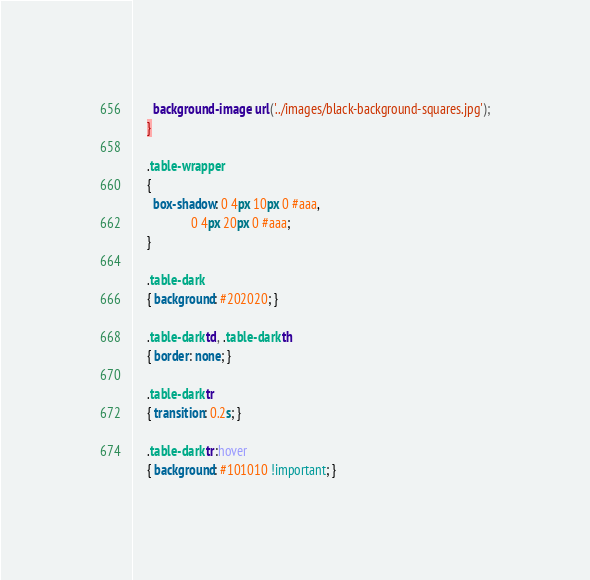<code> <loc_0><loc_0><loc_500><loc_500><_CSS_>      background-image: url('../images/black-background-squares.jpg');
    }
    
    .table-wrapper
    { 
      box-shadow: 0 4px 10px 0 #aaa, 
                  0 4px 20px 0 #aaa; 
    }

    .table-dark
    { background: #202020; }

    .table-dark td, .table-dark th
    { border: none; }

    .table-dark tr
    { transition: 0.2s; }

    .table-dark tr:hover
    { background: #101010 !important; }</code> 